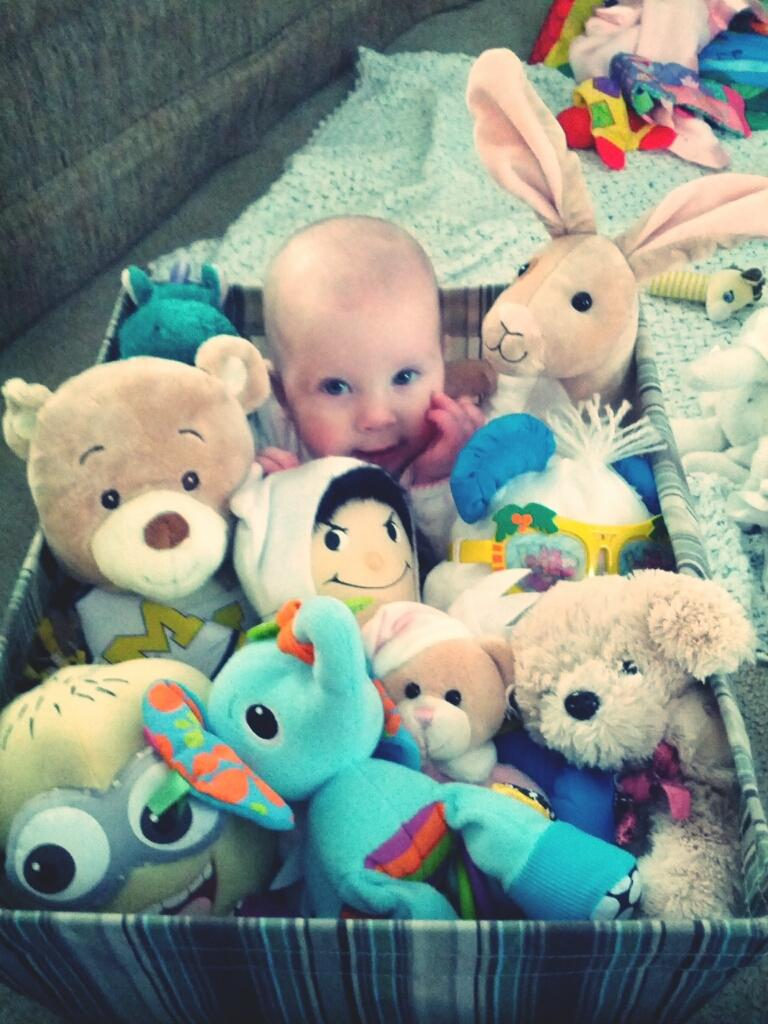What objects can be seen in the image? There are toys in the image. What is the baby doing in the image? The baby is in a basket. What is the view from the baby's perspective in the image? There is no information provided about the baby's perspective or the view in the image. 